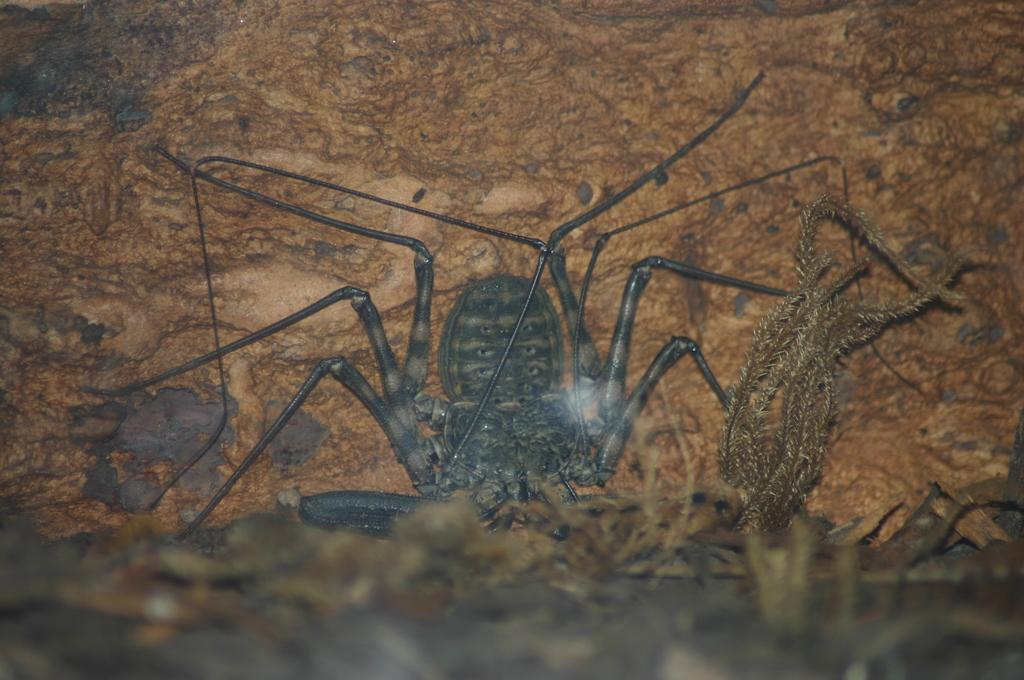What type of creature can be seen in the image? There is an insect in the image. Where is the insect located? The insect is on the ground. What else can be seen in the image besides the insect? There are leaves visible in the image. How does the beggar interact with the insect in the image? There is no beggar present in the image, so there is no interaction between a beggar and the insect. 